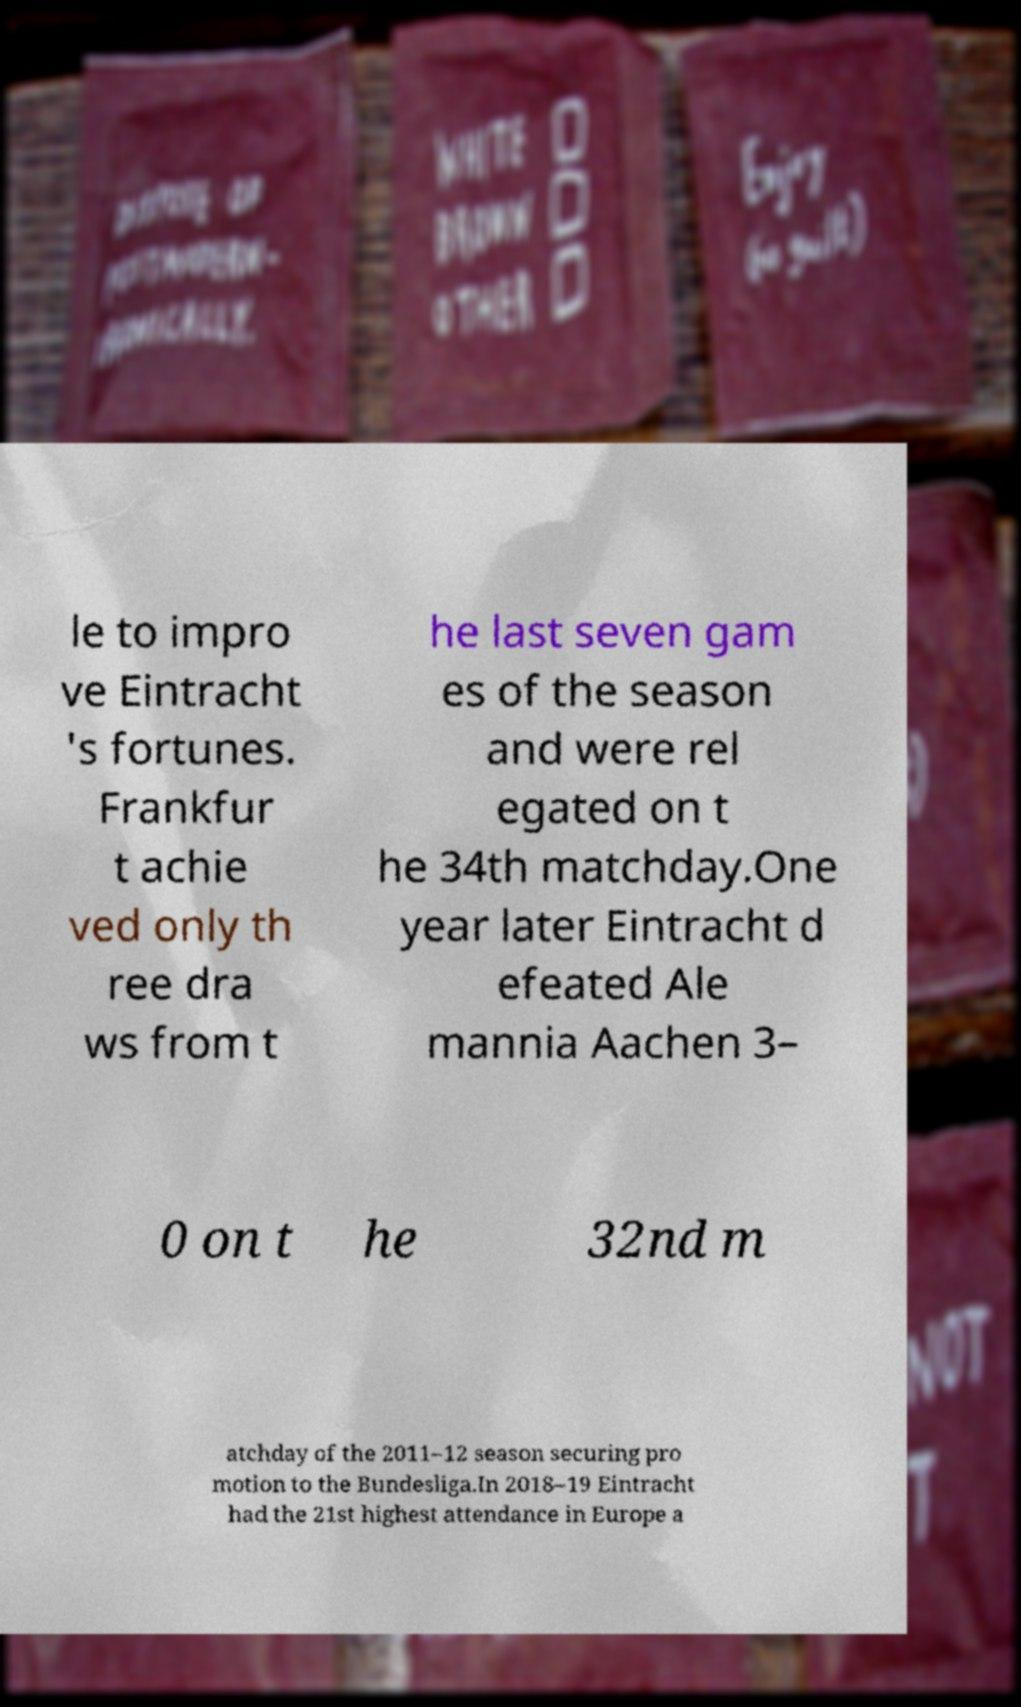What messages or text are displayed in this image? I need them in a readable, typed format. le to impro ve Eintracht 's fortunes. Frankfur t achie ved only th ree dra ws from t he last seven gam es of the season and were rel egated on t he 34th matchday.One year later Eintracht d efeated Ale mannia Aachen 3– 0 on t he 32nd m atchday of the 2011–12 season securing pro motion to the Bundesliga.In 2018–19 Eintracht had the 21st highest attendance in Europe a 